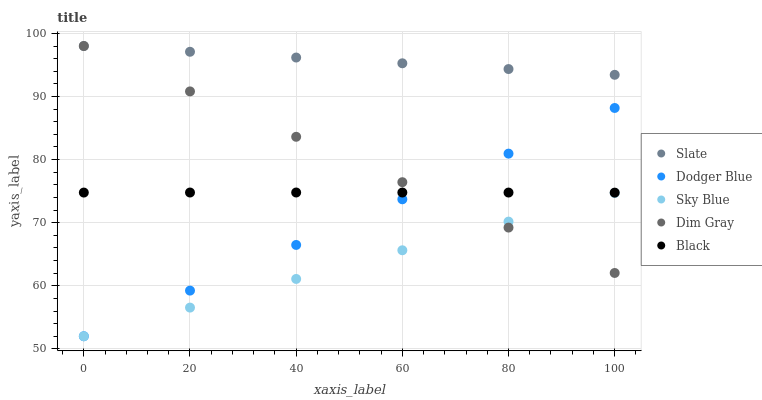Does Sky Blue have the minimum area under the curve?
Answer yes or no. Yes. Does Slate have the maximum area under the curve?
Answer yes or no. Yes. Does Dim Gray have the minimum area under the curve?
Answer yes or no. No. Does Dim Gray have the maximum area under the curve?
Answer yes or no. No. Is Dodger Blue the smoothest?
Answer yes or no. Yes. Is Black the roughest?
Answer yes or no. Yes. Is Slate the smoothest?
Answer yes or no. No. Is Slate the roughest?
Answer yes or no. No. Does Sky Blue have the lowest value?
Answer yes or no. Yes. Does Dim Gray have the lowest value?
Answer yes or no. No. Does Dim Gray have the highest value?
Answer yes or no. Yes. Does Dodger Blue have the highest value?
Answer yes or no. No. Is Dodger Blue less than Slate?
Answer yes or no. Yes. Is Black greater than Sky Blue?
Answer yes or no. Yes. Does Dim Gray intersect Dodger Blue?
Answer yes or no. Yes. Is Dim Gray less than Dodger Blue?
Answer yes or no. No. Is Dim Gray greater than Dodger Blue?
Answer yes or no. No. Does Dodger Blue intersect Slate?
Answer yes or no. No. 